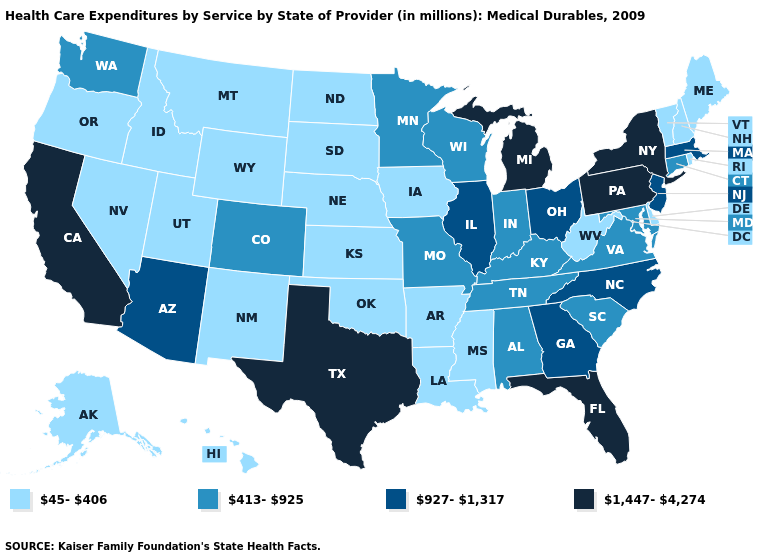What is the value of Alaska?
Concise answer only. 45-406. Is the legend a continuous bar?
Short answer required. No. What is the value of North Dakota?
Be succinct. 45-406. Name the states that have a value in the range 927-1,317?
Write a very short answer. Arizona, Georgia, Illinois, Massachusetts, New Jersey, North Carolina, Ohio. Name the states that have a value in the range 1,447-4,274?
Write a very short answer. California, Florida, Michigan, New York, Pennsylvania, Texas. Name the states that have a value in the range 413-925?
Quick response, please. Alabama, Colorado, Connecticut, Indiana, Kentucky, Maryland, Minnesota, Missouri, South Carolina, Tennessee, Virginia, Washington, Wisconsin. Does New Hampshire have a lower value than Hawaii?
Keep it brief. No. Is the legend a continuous bar?
Be succinct. No. What is the value of South Carolina?
Concise answer only. 413-925. Which states have the lowest value in the MidWest?
Keep it brief. Iowa, Kansas, Nebraska, North Dakota, South Dakota. Which states have the highest value in the USA?
Keep it brief. California, Florida, Michigan, New York, Pennsylvania, Texas. Name the states that have a value in the range 1,447-4,274?
Be succinct. California, Florida, Michigan, New York, Pennsylvania, Texas. What is the value of Alaska?
Quick response, please. 45-406. Does the first symbol in the legend represent the smallest category?
Keep it brief. Yes. Name the states that have a value in the range 45-406?
Give a very brief answer. Alaska, Arkansas, Delaware, Hawaii, Idaho, Iowa, Kansas, Louisiana, Maine, Mississippi, Montana, Nebraska, Nevada, New Hampshire, New Mexico, North Dakota, Oklahoma, Oregon, Rhode Island, South Dakota, Utah, Vermont, West Virginia, Wyoming. 